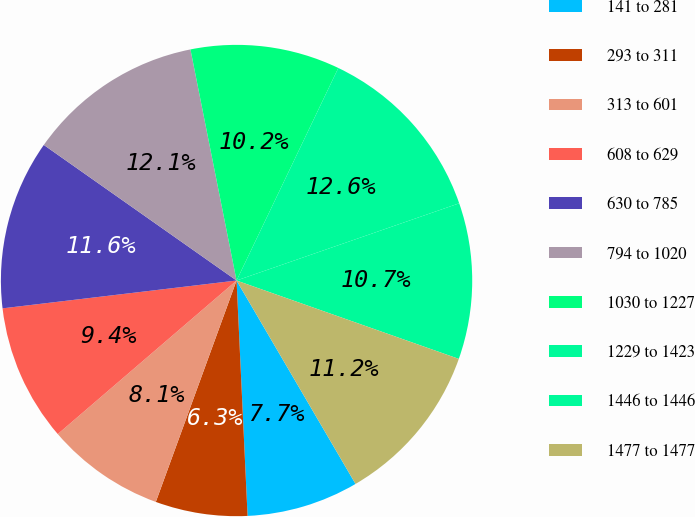Convert chart. <chart><loc_0><loc_0><loc_500><loc_500><pie_chart><fcel>141 to 281<fcel>293 to 311<fcel>313 to 601<fcel>608 to 629<fcel>630 to 785<fcel>794 to 1020<fcel>1030 to 1227<fcel>1229 to 1423<fcel>1446 to 1446<fcel>1477 to 1477<nl><fcel>7.68%<fcel>6.31%<fcel>8.14%<fcel>9.41%<fcel>11.64%<fcel>12.11%<fcel>10.24%<fcel>12.58%<fcel>10.71%<fcel>11.18%<nl></chart> 